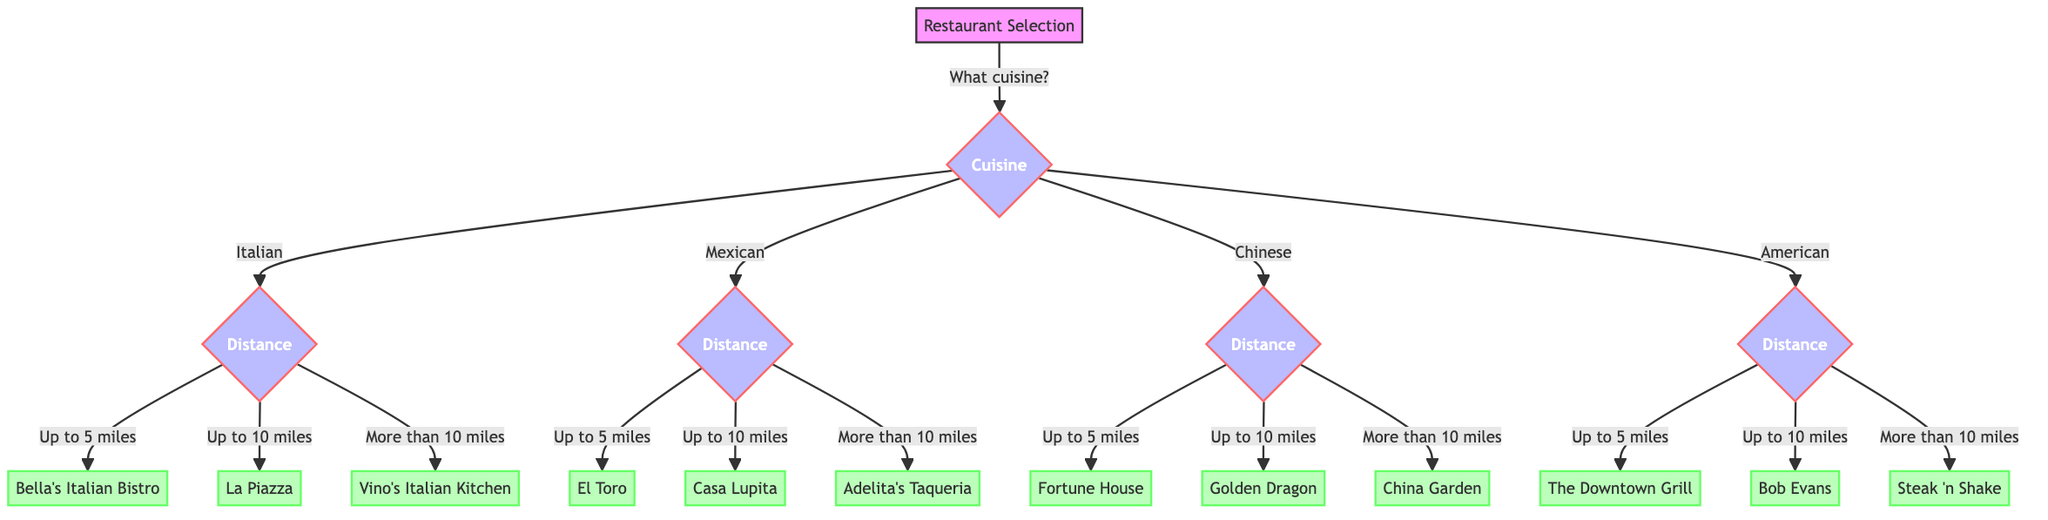What type of cuisine can I choose from? The diagram starts with a question about cuisine type, branching into four distinct options: Italian, Mexican, Chinese, and American.
Answer: Italian, Mexican, Chinese, American How many restaurants are listed for Mexican cuisine? The Mexican cuisine branch leads to three options based on distance: El Toro, Casa Lupita, and Adelita's Taqueria, so there are three restaurants listed.
Answer: Three What restaurant should I choose if I want Italian cuisine and I am willing to travel more than 10 miles? Following the Italian option, the next question about distance is asked. If the answer is "more than 10 miles," the decision leads directly to Vino's Italian Kitchen as the resulting restaurant.
Answer: Vino's Italian Kitchen Which restaurant is the closest option if I select Chinese cuisine? The diagram indicates that the first distance option under Chinese cuisine is "Up to 5 miles," leading to Fortune House. This is the closest restaurant available under that cuisine.
Answer: Fortune House If I want American cuisine and I am willing to travel up to 10 miles, what restaurant will I find? Starting with the American cuisine branch, the distance options are examined, and "up to 10 miles" leads to Bob Evans, which is the appropriate restaurant choice within this range.
Answer: Bob Evans If I choose Mexican food and I want to go up to 5 miles, what will be the outcome? In the Mexican cuisine branch, the choice of "up to 5 miles" leads directly to El Toro, making that the outcome for this specific preference.
Answer: El Toro What is the total number of restaurants in the diagram? The diagram outlines a total of 12 restaurants across all cuisine types and distance options combined. This is calculated by adding the individual options per cuisine.
Answer: Twelve Which cuisine has the most choices based on distance options? All cuisines provide three options based on distance, so they are all equal in this aspect. Thus, there are no cuisines with more than three choices—each category matches this criteria.
Answer: All cuisines are equal 